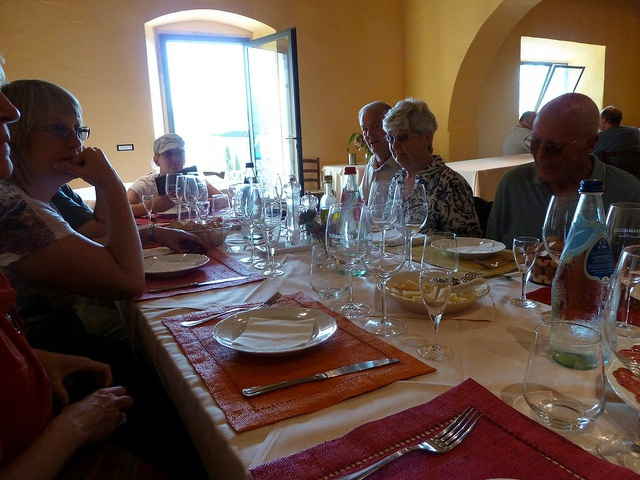Describe the objects in this image and their specific colors. I can see dining table in brown, gray, maroon, and black tones, dining table in brown, gray, maroon, and black tones, people in brown, black, maroon, gray, and white tones, dining table in brown, gray, maroon, and black tones, and people in brown, black, maroon, and gray tones in this image. 